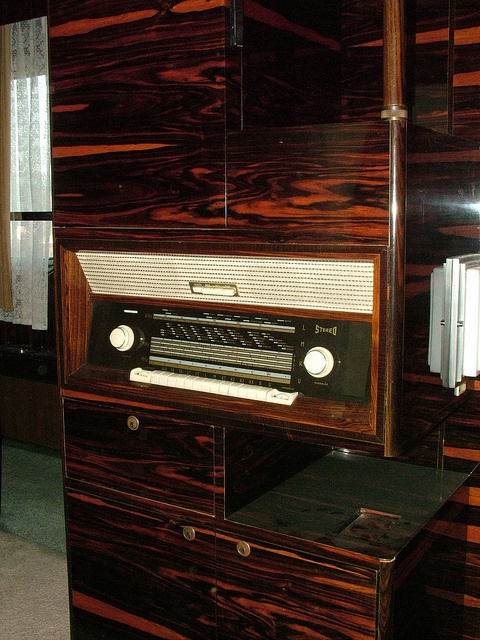Describe the objects in this image and their specific colors. I can see various objects in this image with different colors. 